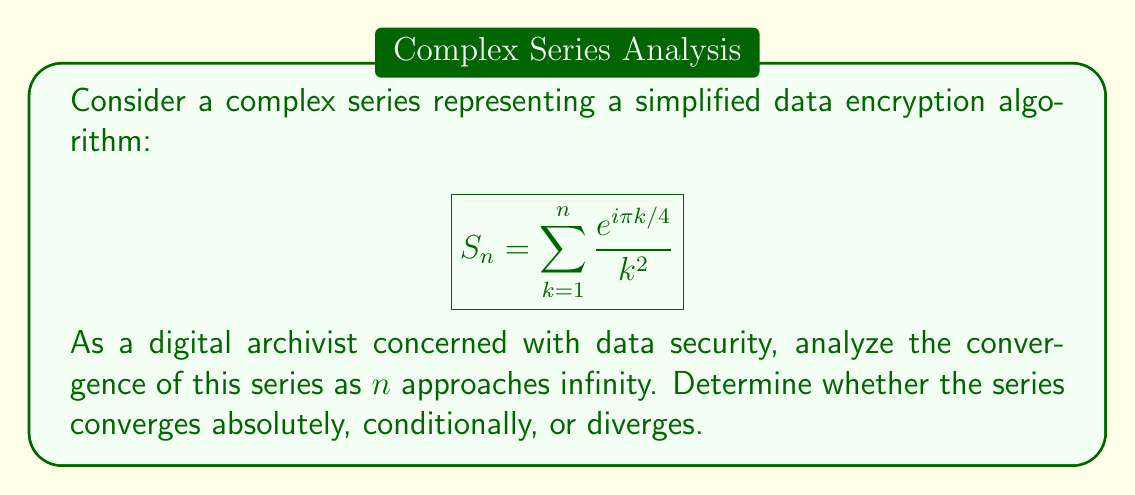Solve this math problem. To analyze the convergence of this complex series, we'll follow these steps:

1. Check for absolute convergence:
   We'll use the comparison test with a p-series.
   
   $$\left|\frac{e^{i\pi k/4}}{k^2}\right| = \frac{|e^{i\pi k/4}|}{k^2} = \frac{1}{k^2}$$
   
   The series $\sum_{k=1}^{\infty} \frac{1}{k^2}$ is a p-series with $p=2 > 1$, which converges.
   Therefore, our original series converges absolutely.

2. Verify convergence using the limit of the sequence of partial sums:
   Let $S = \lim_{n\to\infty} S_n$. We can express this as:
   
   $$S = \sum_{k=1}^{\infty} \frac{e^{i\pi k/4}}{k^2}$$
   
   This can be written in terms of polylogarithm function:
   
   $$S = \text{Li}_2(e^{i\pi/4})$$
   
   Where $\text{Li}_2(z)$ is the dilogarithm function, which is well-defined for $|z| \leq 1$.

3. Conclusion:
   Since $|e^{i\pi/4}| = 1$, the series converges to a finite complex value.

From an ethical perspective, this convergence analysis demonstrates that even simplified encryption algorithms can have complex mathematical properties. As a digital archivist, understanding these properties is crucial for assessing the robustness and security of data encryption methods used in big data and surveillance contexts.
Answer: The series $S_n = \sum_{k=1}^n \frac{e^{i\pi k/4}}{k^2}$ converges absolutely as $n$ approaches infinity. The sum of the series can be expressed as $S = \text{Li}_2(e^{i\pi/4})$, where $\text{Li}_2$ is the dilogarithm function. 